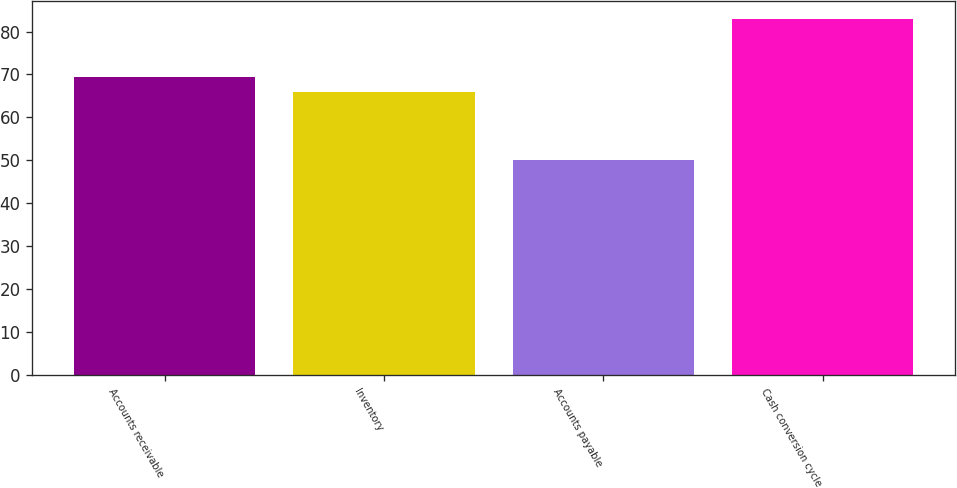Convert chart to OTSL. <chart><loc_0><loc_0><loc_500><loc_500><bar_chart><fcel>Accounts receivable<fcel>Inventory<fcel>Accounts payable<fcel>Cash conversion cycle<nl><fcel>69.3<fcel>66<fcel>50<fcel>83<nl></chart> 